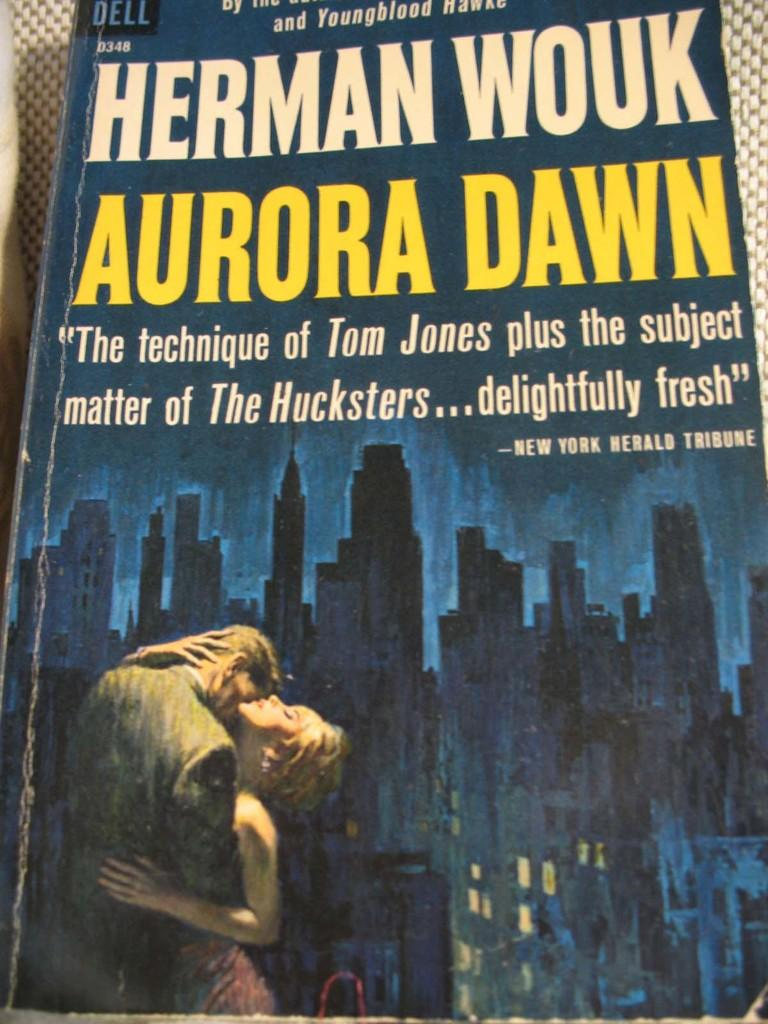Provide a one-sentence caption for the provided image. Herman Wouk's Aurora Dawn has a review by the New York Herald Tribune on its cover. 